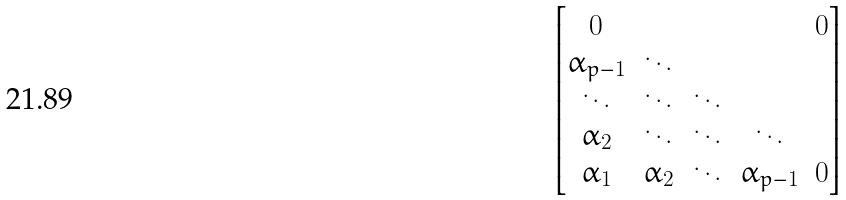Convert formula to latex. <formula><loc_0><loc_0><loc_500><loc_500>\begin{bmatrix} 0 & & & & 0 \\ \alpha _ { p - 1 } & \ddots \\ \ddots & \ddots & \ddots \\ \alpha _ { 2 } & \ddots & \ddots & \ddots \\ \alpha _ { 1 } & \alpha _ { 2 } & \ddots & \alpha _ { p - 1 } & 0 \end{bmatrix}</formula> 